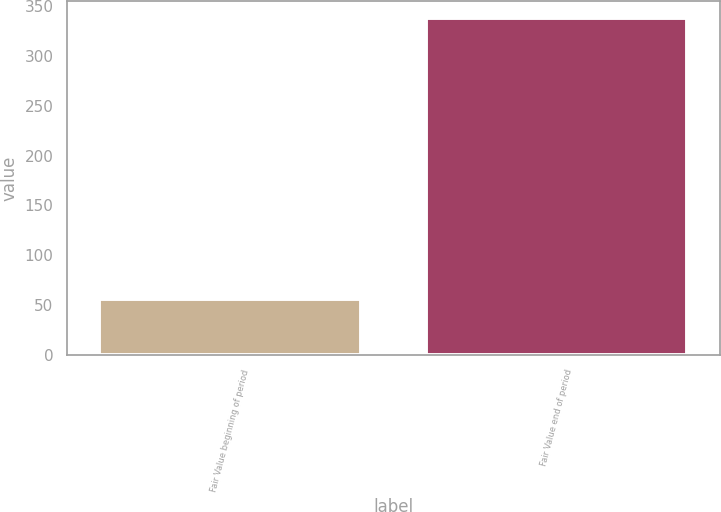<chart> <loc_0><loc_0><loc_500><loc_500><bar_chart><fcel>Fair Value beginning of period<fcel>Fair Value end of period<nl><fcel>56<fcel>338<nl></chart> 